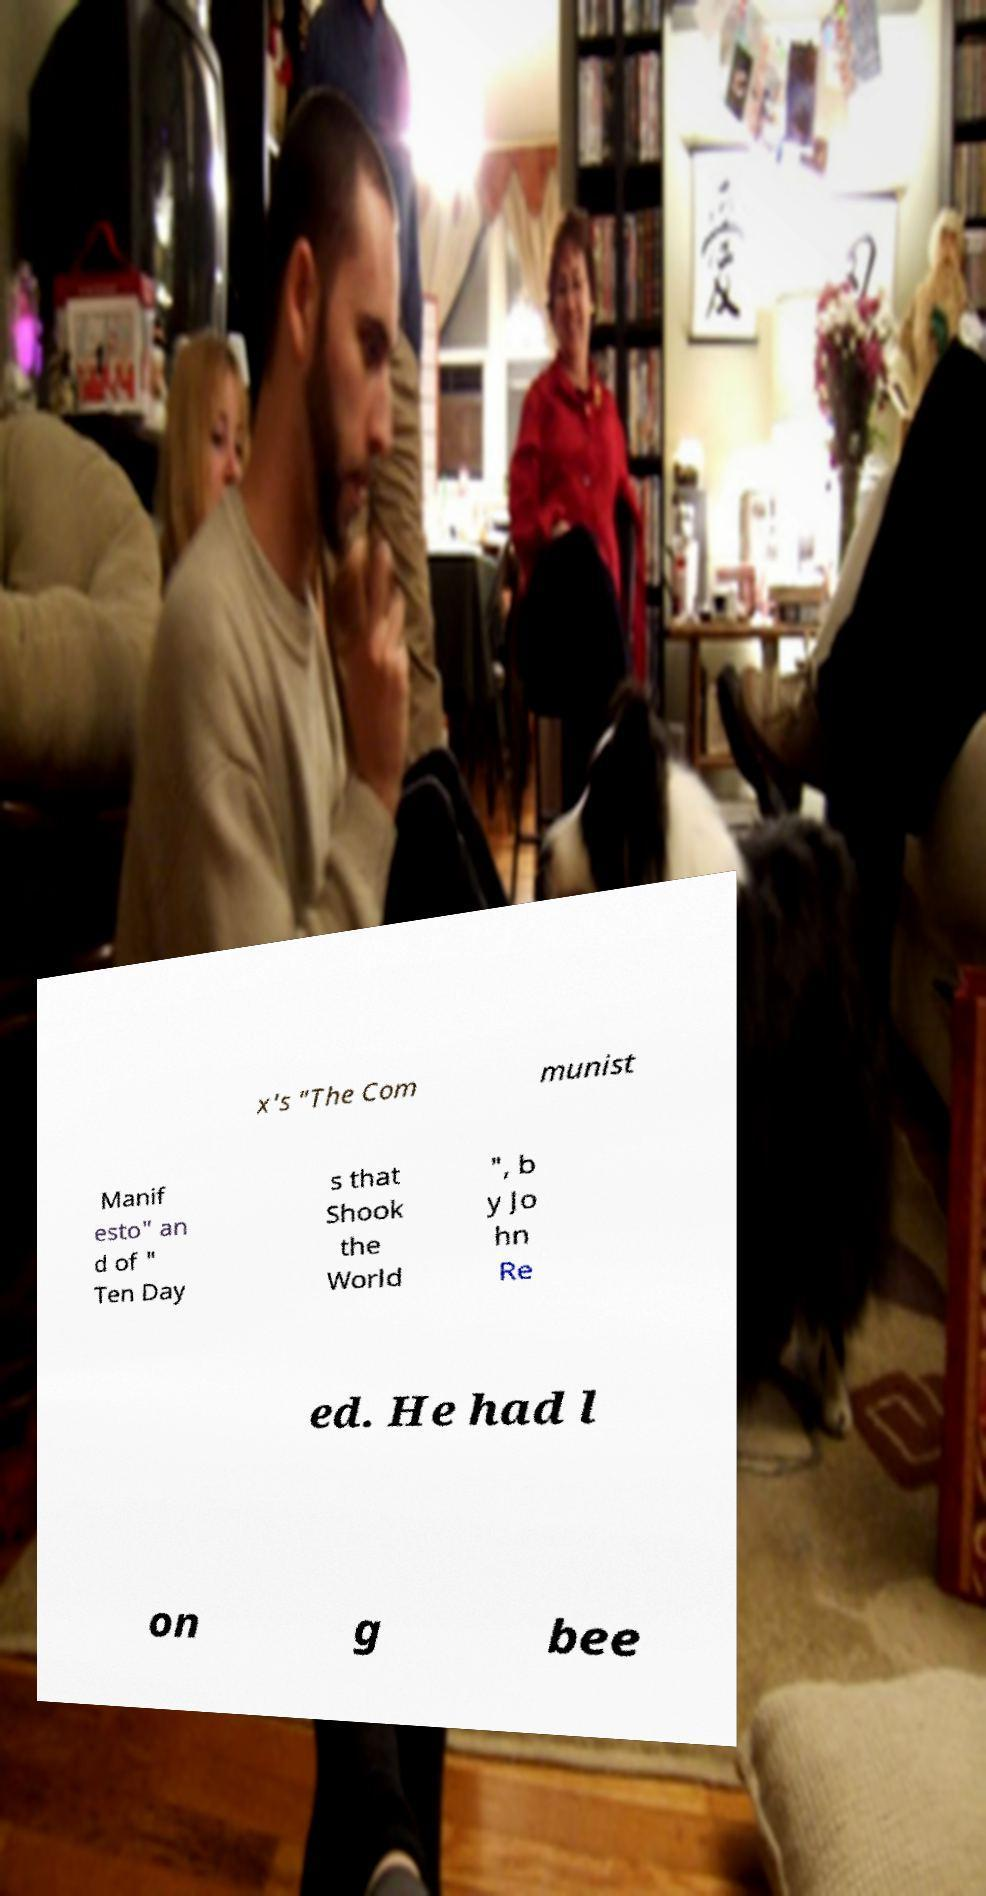Can you accurately transcribe the text from the provided image for me? x's "The Com munist Manif esto" an d of " Ten Day s that Shook the World ", b y Jo hn Re ed. He had l on g bee 